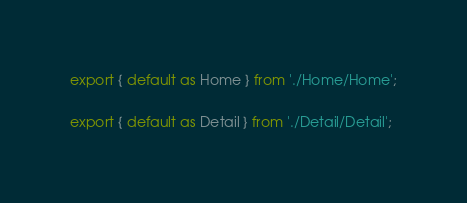Convert code to text. <code><loc_0><loc_0><loc_500><loc_500><_JavaScript_>export { default as Home } from './Home/Home';

export { default as Detail } from './Detail/Detail';</code> 